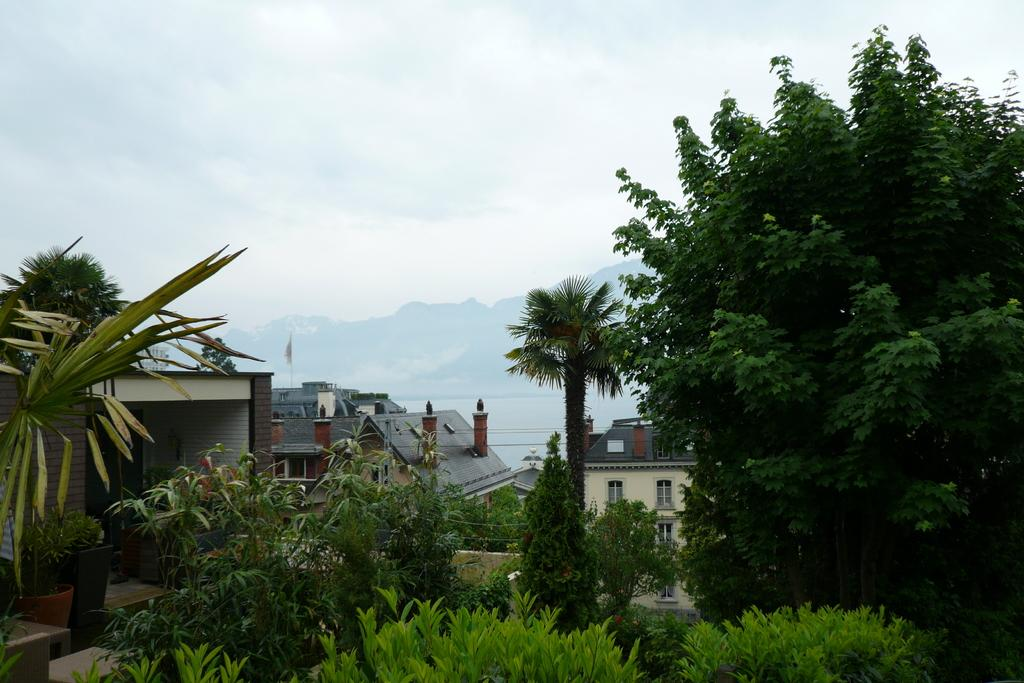What can be seen in the foreground of the image? There are trees and houses in the foreground of the image. What is visible in the background of the image? There are mountains, sky, and clouds visible in the background of the image. What type of underwear is hanging on the trees in the image? There is no underwear present in the image; it features trees, houses, mountains, sky, and clouds. What color is the hair of the trees in the image? Trees do not have hair, so this question is not applicable to the image. 